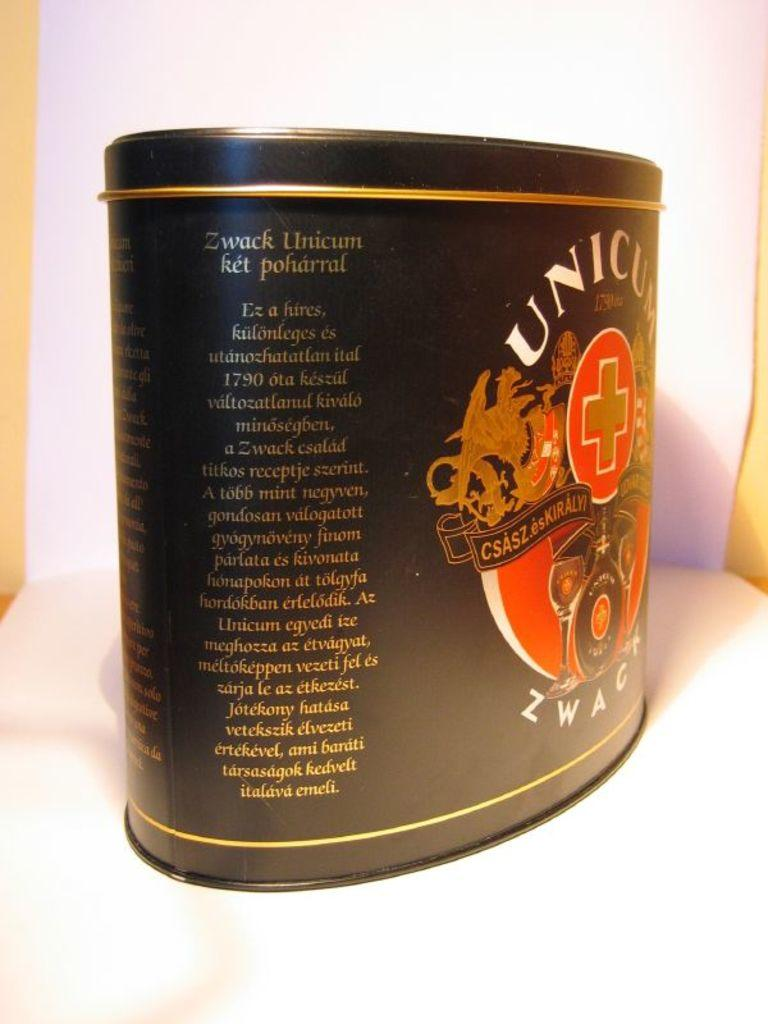<image>
Relay a brief, clear account of the picture shown. A black tin says Unicum in white letters. 